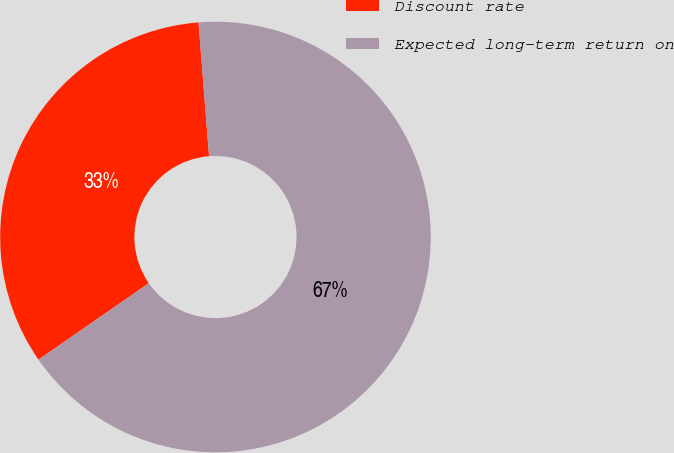Convert chart to OTSL. <chart><loc_0><loc_0><loc_500><loc_500><pie_chart><fcel>Discount rate<fcel>Expected long-term return on<nl><fcel>33.39%<fcel>66.61%<nl></chart> 